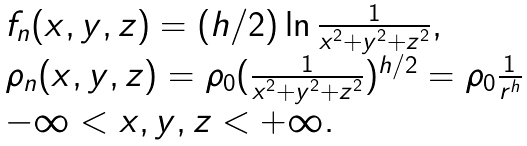<formula> <loc_0><loc_0><loc_500><loc_500>\begin{array} { l } f _ { n } ( x , y , z ) = ( h / 2 ) \ln \frac { 1 } { x ^ { 2 } + y ^ { 2 } + z ^ { 2 } } , \\ \rho _ { n } ( x , y , z ) = \rho _ { 0 } ( \frac { 1 } { x ^ { 2 } + y ^ { 2 } + z ^ { 2 } } ) ^ { h / 2 } = \rho _ { 0 } \frac { 1 } { r ^ { h } } \\ - \infty < x , y , z < + \infty . \end{array}</formula> 